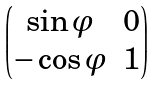<formula> <loc_0><loc_0><loc_500><loc_500>\begin{pmatrix} \sin \varphi & 0 \\ - \cos \varphi & 1 \end{pmatrix}</formula> 